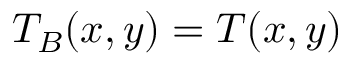Convert formula to latex. <formula><loc_0><loc_0><loc_500><loc_500>T _ { B } ( x , y ) = T ( x , y )</formula> 